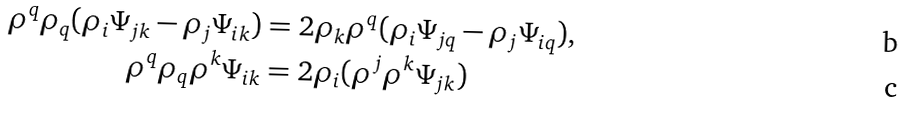Convert formula to latex. <formula><loc_0><loc_0><loc_500><loc_500>\rho ^ { q } \rho _ { q } ( \rho _ { i } \Psi _ { j k } - \rho _ { j } \Psi _ { i k } ) & = 2 \rho _ { k } \rho ^ { q } ( \rho _ { i } \Psi _ { j q } - \rho _ { j } \Psi _ { i q } ) , \\ \rho ^ { q } \rho _ { q } \rho ^ { k } \Psi _ { i k } & = 2 \rho _ { i } ( \rho ^ { j } \rho ^ { k } \Psi _ { j k } )</formula> 